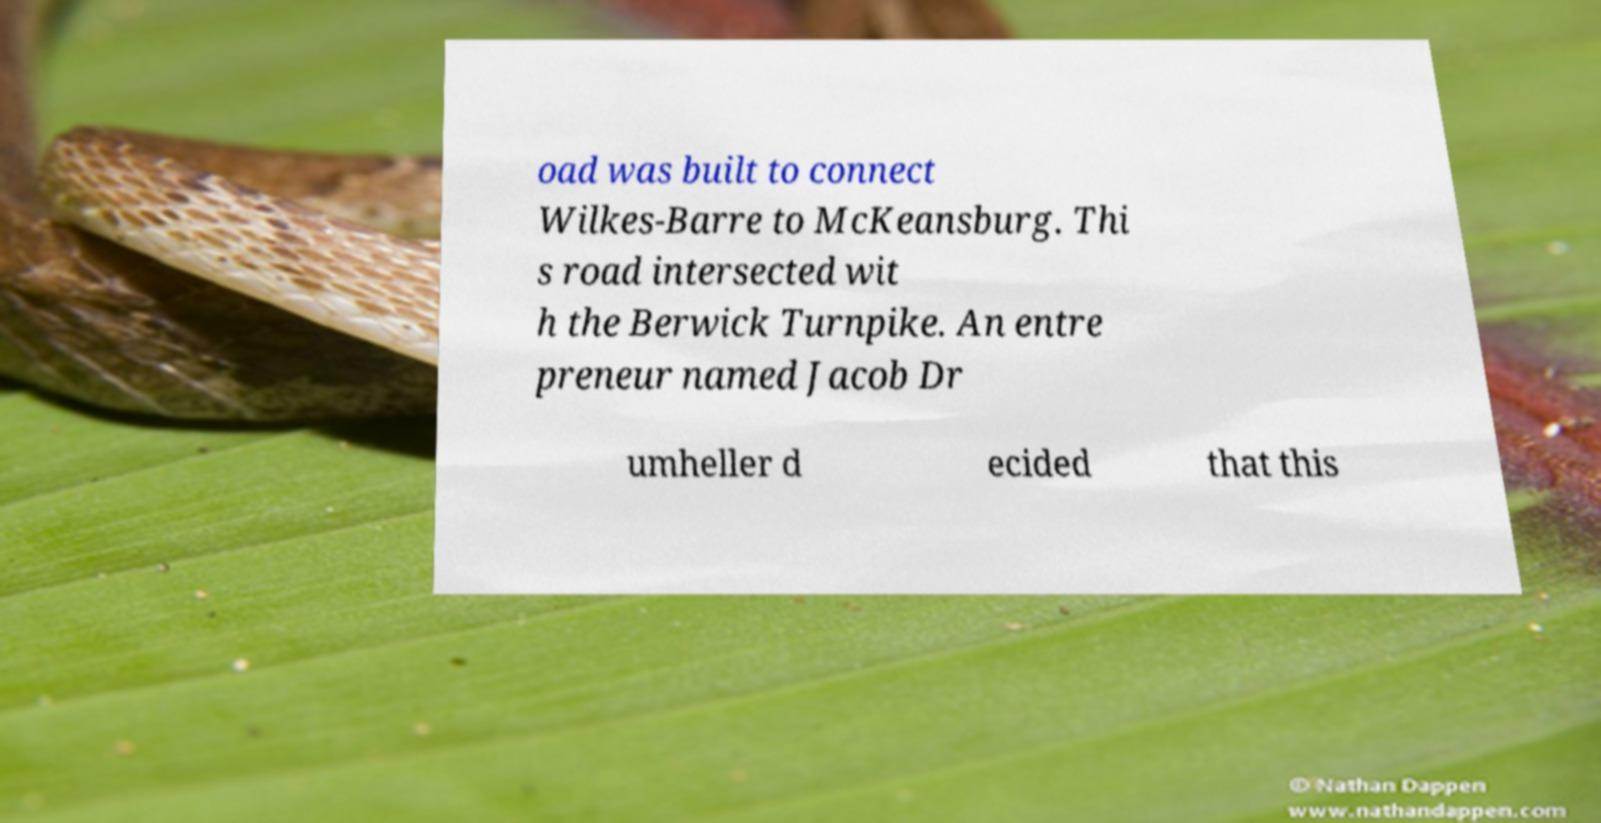Could you assist in decoding the text presented in this image and type it out clearly? oad was built to connect Wilkes-Barre to McKeansburg. Thi s road intersected wit h the Berwick Turnpike. An entre preneur named Jacob Dr umheller d ecided that this 